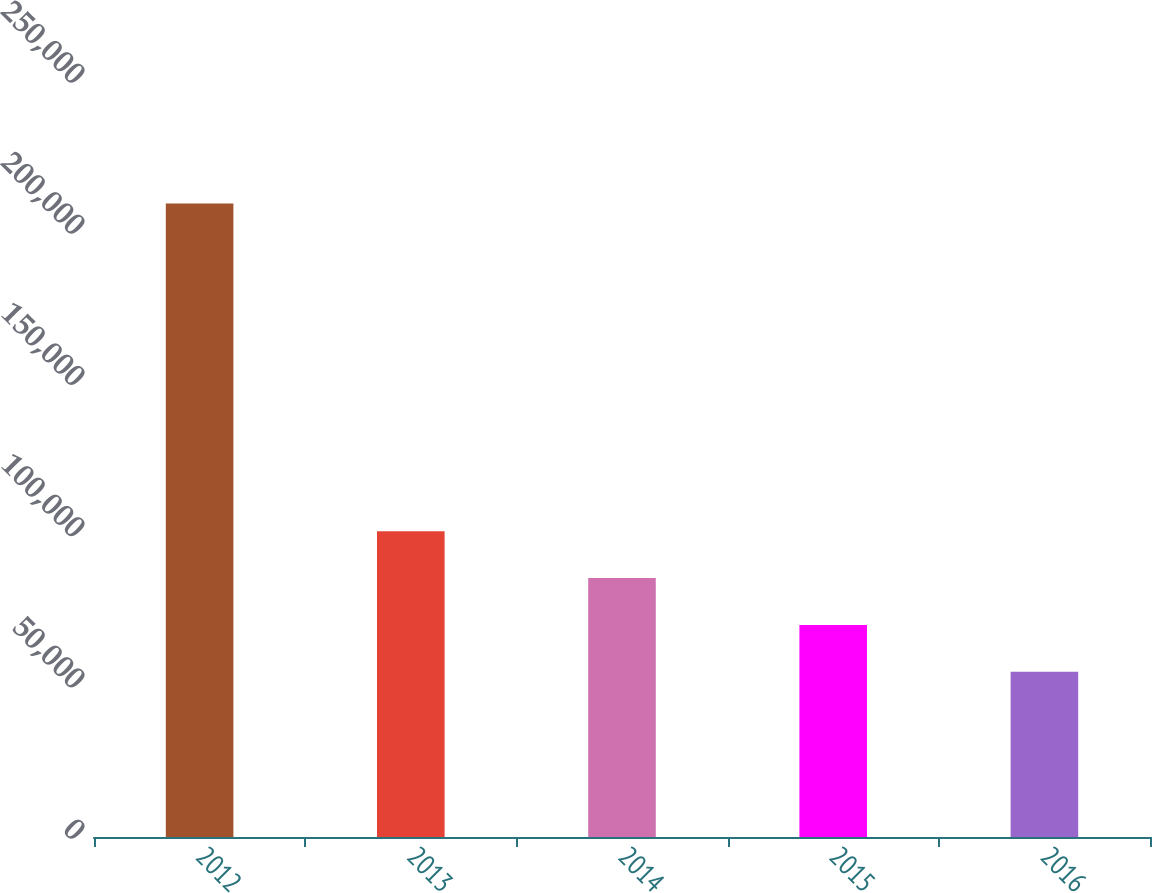<chart> <loc_0><loc_0><loc_500><loc_500><bar_chart><fcel>2012<fcel>2013<fcel>2014<fcel>2015<fcel>2016<nl><fcel>209469<fcel>101097<fcel>85615.4<fcel>70133.7<fcel>54652<nl></chart> 